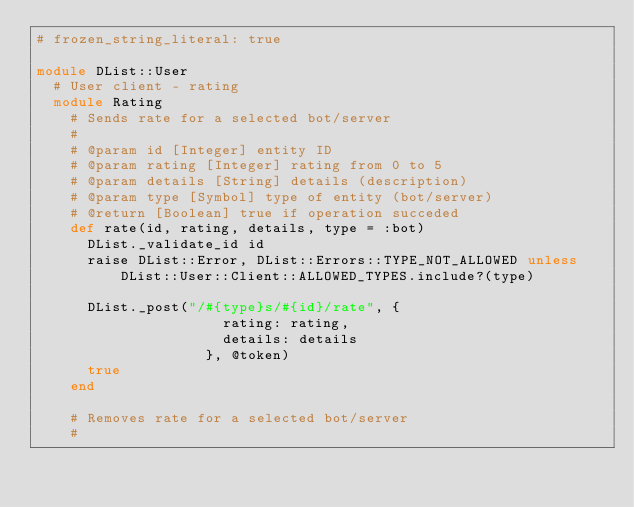Convert code to text. <code><loc_0><loc_0><loc_500><loc_500><_Ruby_># frozen_string_literal: true

module DList::User
  # User client - rating
  module Rating
    # Sends rate for a selected bot/server
    #
    # @param id [Integer] entity ID
    # @param rating [Integer] rating from 0 to 5
    # @param details [String] details (description)
    # @param type [Symbol] type of entity (bot/server)
    # @return [Boolean] true if operation succeded
    def rate(id, rating, details, type = :bot)
      DList._validate_id id
      raise DList::Error, DList::Errors::TYPE_NOT_ALLOWED unless DList::User::Client::ALLOWED_TYPES.include?(type)

      DList._post("/#{type}s/#{id}/rate", {
                      rating: rating,
                      details: details
                    }, @token)
      true
    end

    # Removes rate for a selected bot/server
    #</code> 